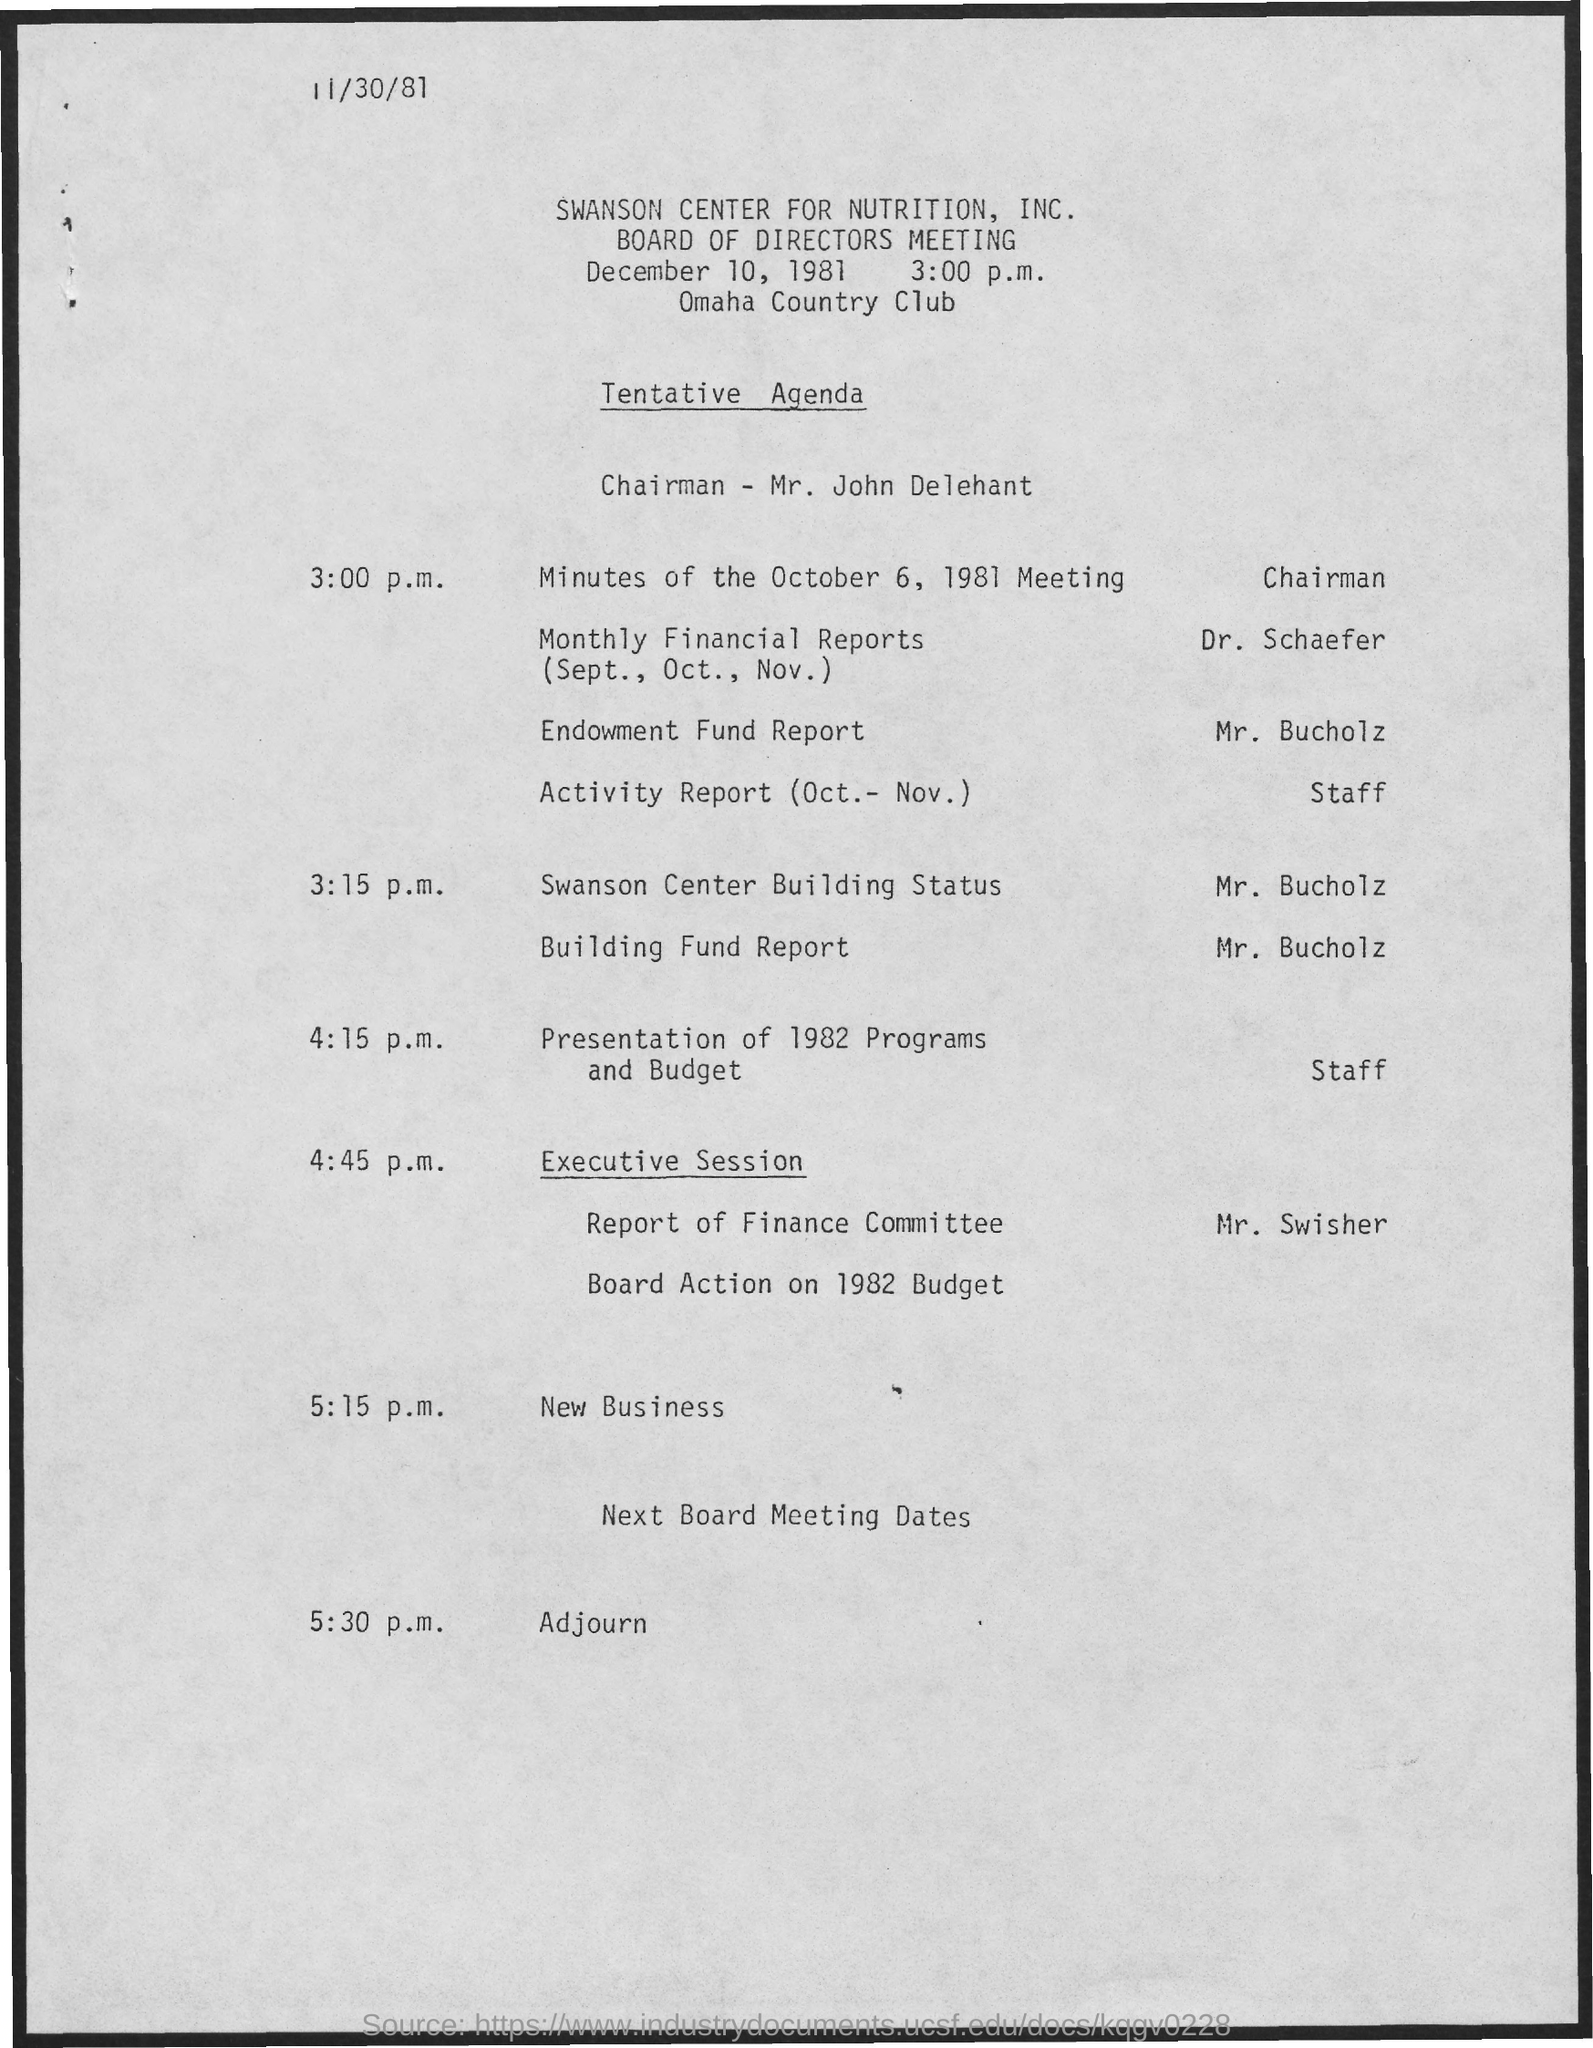Who presented the Monthly financial reports (Sept., Oct., Nov. ) in the meeting?
Your response must be concise. Dr. Schaefer. Who is presenting the Endowment Fund Report as per the agenda?
Give a very brief answer. Mr. Bucholz. At What time, Mr. Bucholz is presenting Building Fund Report as per the agenda?
Your response must be concise. 3:15 p.m. Who is presenting the Report of Finance Committe in the meeting?
Ensure brevity in your answer.  Mr. Swisher. At what time, Chairman is presenting the Minutes of the October 6, 1981 Meeting?
Keep it short and to the point. 3:00 p.m. What date is the Board of Directors Meeting held?
Make the answer very short. December 10, 1981. Where is the Board of Directors Meeting held?
Offer a very short reply. Omaha country club. 